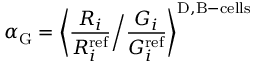Convert formula to latex. <formula><loc_0><loc_0><loc_500><loc_500>\alpha _ { G } = \left \langle \frac { R _ { i } } { R _ { i } ^ { r e f } } \Big / \frac { G _ { i } } { G _ { i } ^ { r e f } } \right \rangle ^ { D , B - c e l l s }</formula> 